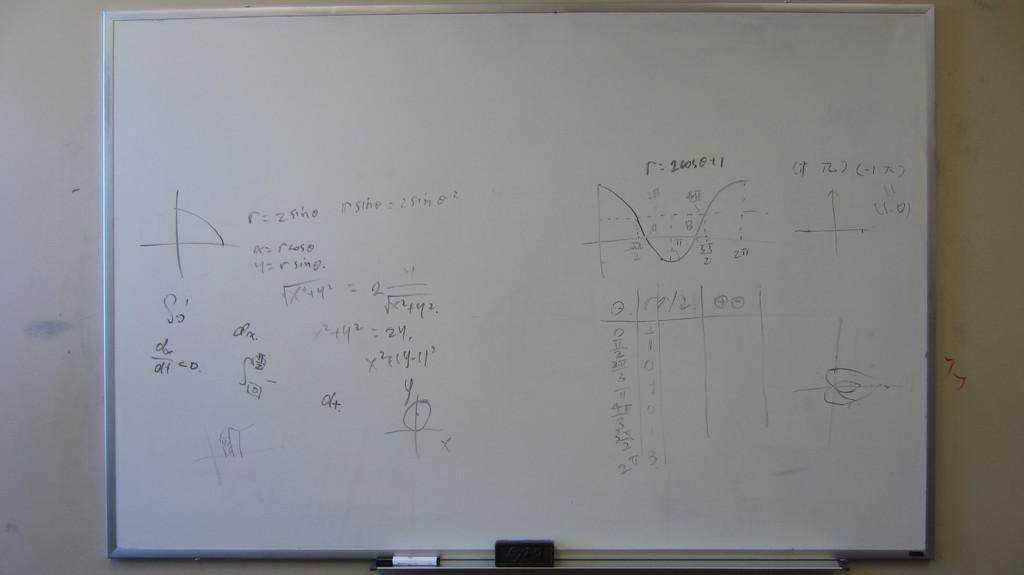<image>
Summarize the visual content of the image. The letter r is seen on a whiteboard, with the letters a and y underneath. 